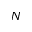<formula> <loc_0><loc_0><loc_500><loc_500>N</formula> 